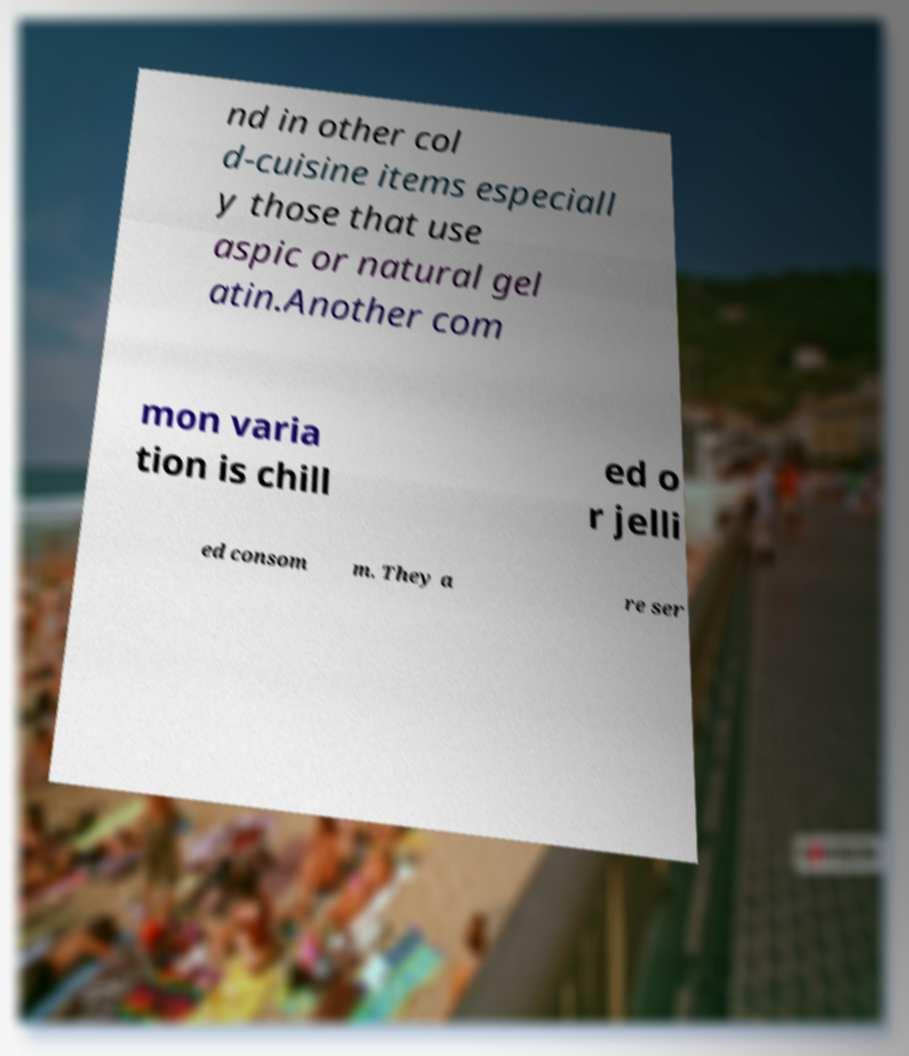Please read and relay the text visible in this image. What does it say? nd in other col d-cuisine items especiall y those that use aspic or natural gel atin.Another com mon varia tion is chill ed o r jelli ed consom m. They a re ser 